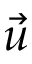Convert formula to latex. <formula><loc_0><loc_0><loc_500><loc_500>\vec { u }</formula> 